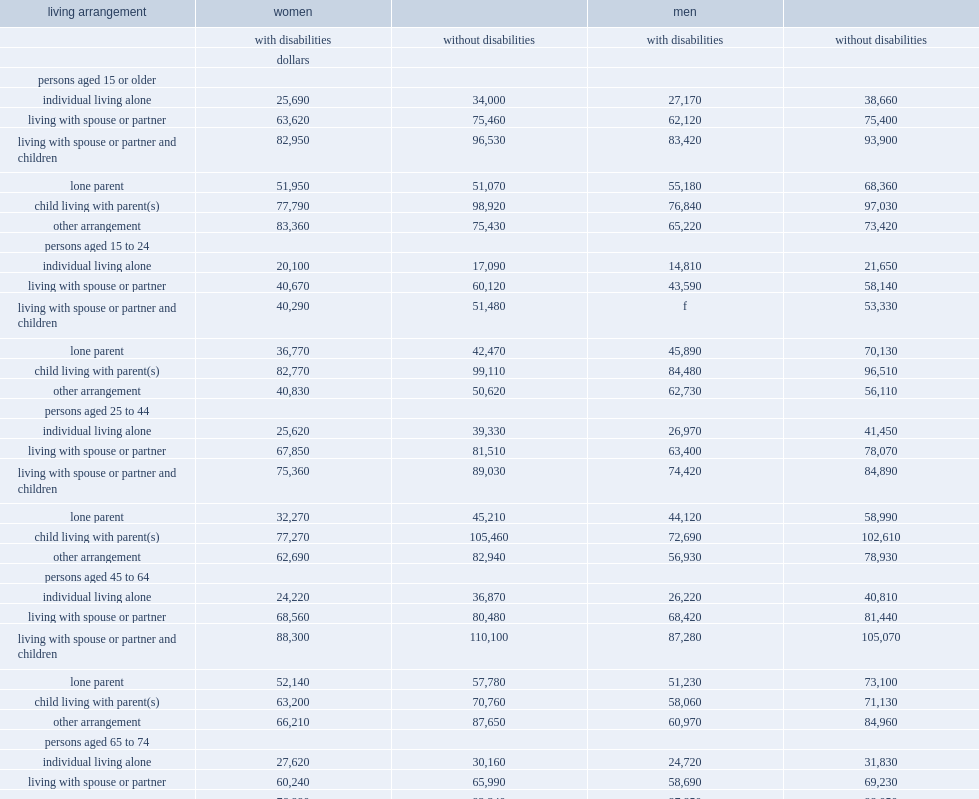Which kind of women aged 15 or older who lived alone reported significantly less household income on average, women without disabilities or women without disabilities? With disabilities. Among men with disabilities aged 15 or older, which kind of household income was the highest ? Living with spouse or partner and children. What was the average household income of women with disabilities aged 15 or older in this living situation? 82950.0. What was the average household income of women without disabilities aged 15 or older in this living situation? 96530.0. What was the average household income of men with disabilities aged 15 or older in this living situation? 83420.0. 